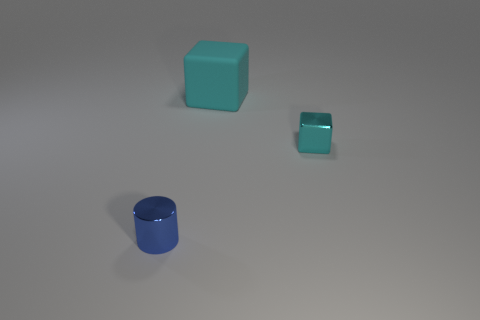Subtract all cyan cubes. How many were subtracted if there are1cyan cubes left? 1 Add 1 large brown matte spheres. How many objects exist? 4 Subtract all blocks. How many objects are left? 1 Add 2 tiny matte spheres. How many tiny matte spheres exist? 2 Subtract 0 green cylinders. How many objects are left? 3 Subtract all tiny cyan cubes. Subtract all small cyan cubes. How many objects are left? 1 Add 1 tiny cylinders. How many tiny cylinders are left? 2 